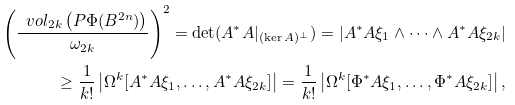Convert formula to latex. <formula><loc_0><loc_0><loc_500><loc_500>\left ( \frac { \ v o l _ { 2 k } \left ( P \Phi ( B ^ { 2 n } ) \right ) } { \omega _ { 2 k } } \right ) ^ { 2 } = \det ( A ^ { * } A | _ { ( \ker A ) ^ { \perp } } ) = | A ^ { * } A \xi _ { 1 } \wedge \cdots \wedge A ^ { * } A \xi _ { 2 k } | \\ \geq \frac { 1 } { k ! } \left | \Omega ^ { k } [ A ^ { * } A \xi _ { 1 } , \dots , A ^ { * } A \xi _ { 2 k } ] \right | = \frac { 1 } { k ! } \left | \Omega ^ { k } [ \Phi ^ { * } A \xi _ { 1 } , \dots , \Phi ^ { * } A \xi _ { 2 k } ] \right | ,</formula> 